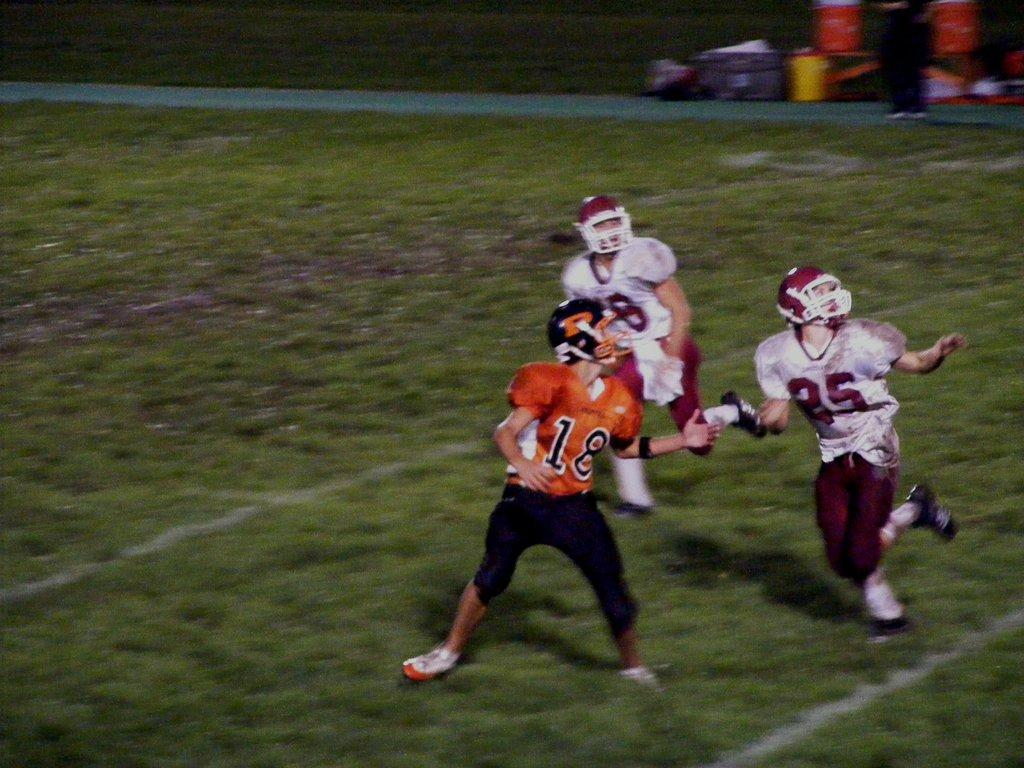How many people are present in the image? There are three people in the image. What are the people wearing on their heads? The people are wearing helmets. What activity are the people engaged in? The people are running in the ground. What type of vegetation can be seen in the image? There is grass visible in the image. What structure is present in the image? There is a wall in the image. What objects can be seen near the people? There are containers in the image. What type of brass instrument is being played by the people in the image? There is no brass instrument present in the image; the people are wearing helmets and running. Can you see an airplane flying in the background of the image? There is no airplane visible in the image; it features three people running, a wall, containers, and grass. 